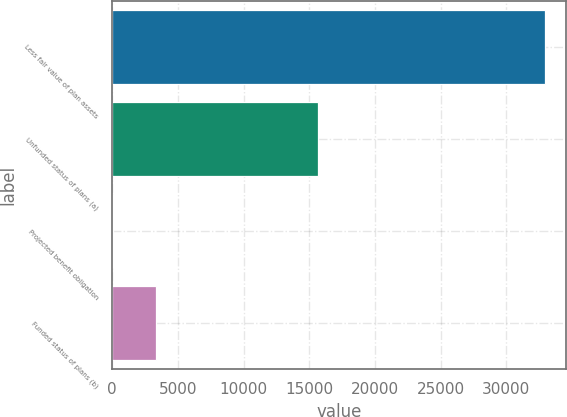Convert chart. <chart><loc_0><loc_0><loc_500><loc_500><bar_chart><fcel>Less fair value of plan assets<fcel>Unfunded status of plans (a)<fcel>Projected benefit obligation<fcel>Funded status of plans (b)<nl><fcel>32925<fcel>15703<fcel>58<fcel>3344.7<nl></chart> 